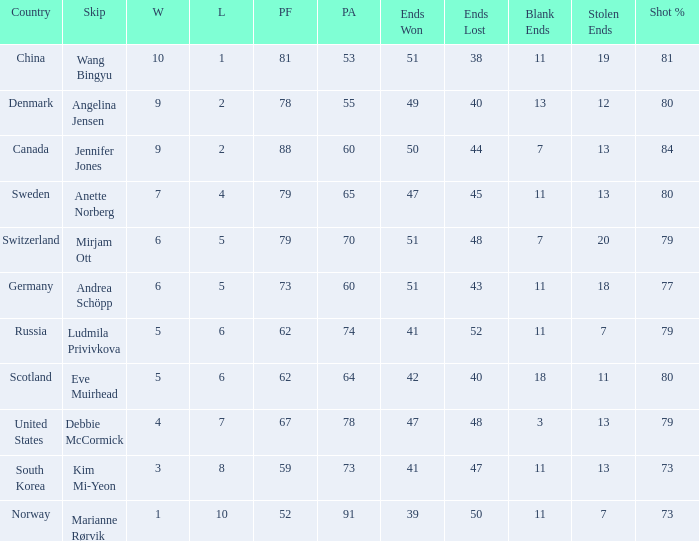What is the minimum Wins a team has? 1.0. 